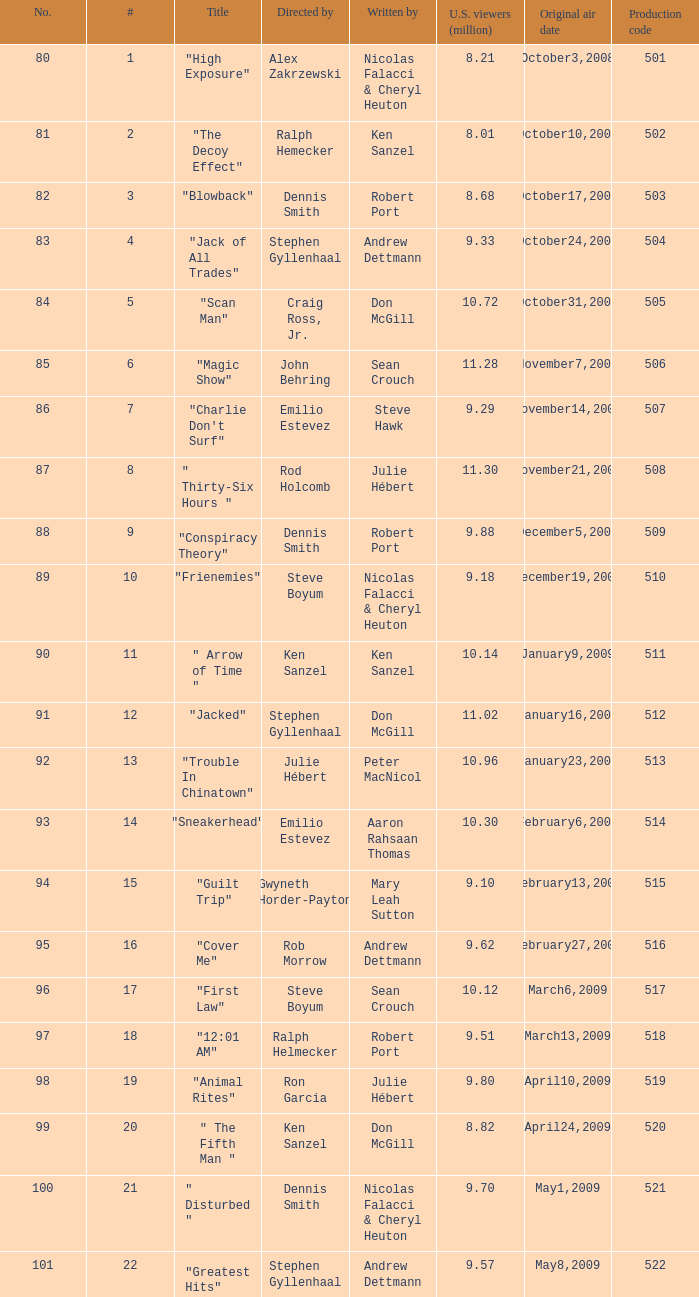What was the episode with 10.14 million american viewers? 11.0. 